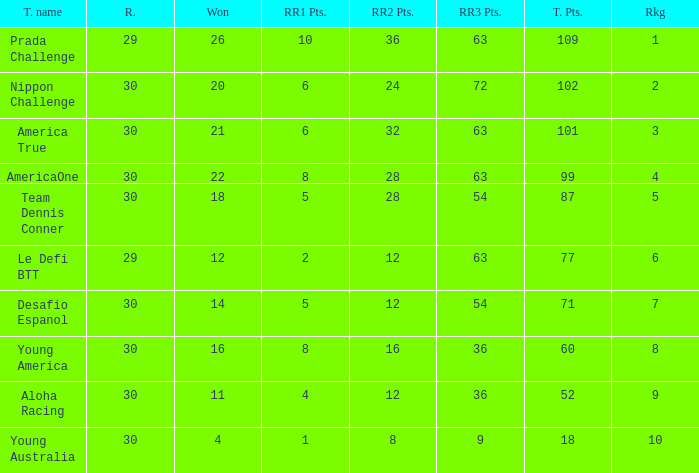Name the races for the prada challenge 29.0. 